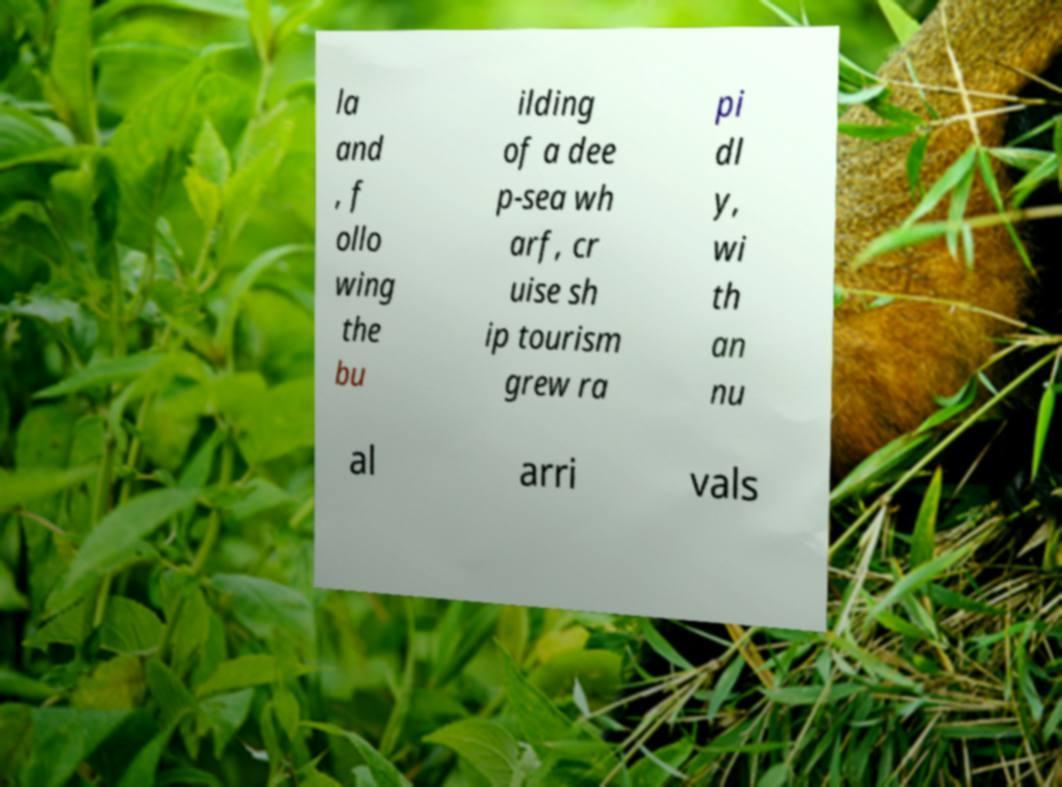Can you read and provide the text displayed in the image?This photo seems to have some interesting text. Can you extract and type it out for me? la and , f ollo wing the bu ilding of a dee p-sea wh arf, cr uise sh ip tourism grew ra pi dl y, wi th an nu al arri vals 